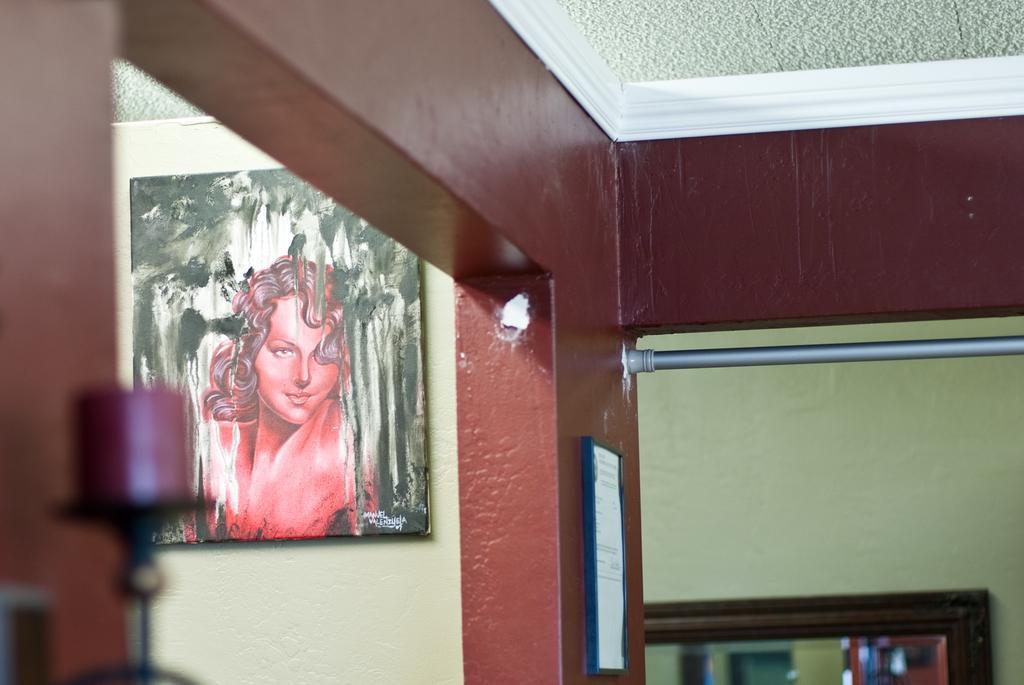In one or two sentences, can you explain what this image depicts? In this image there is a wall and on the wall there is some poster in the center, and on the left side of the image there is a photo frame and an object. On the right side there is a mirror and there is one pole, at the top there is ceiling and in the background there is wall. 